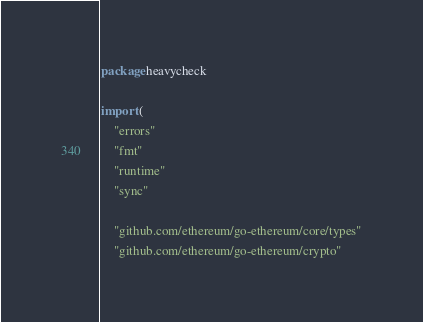<code> <loc_0><loc_0><loc_500><loc_500><_Go_>package heavycheck

import (
	"errors"
	"fmt"
	"runtime"
	"sync"

	"github.com/ethereum/go-ethereum/core/types"
	"github.com/ethereum/go-ethereum/crypto"</code> 